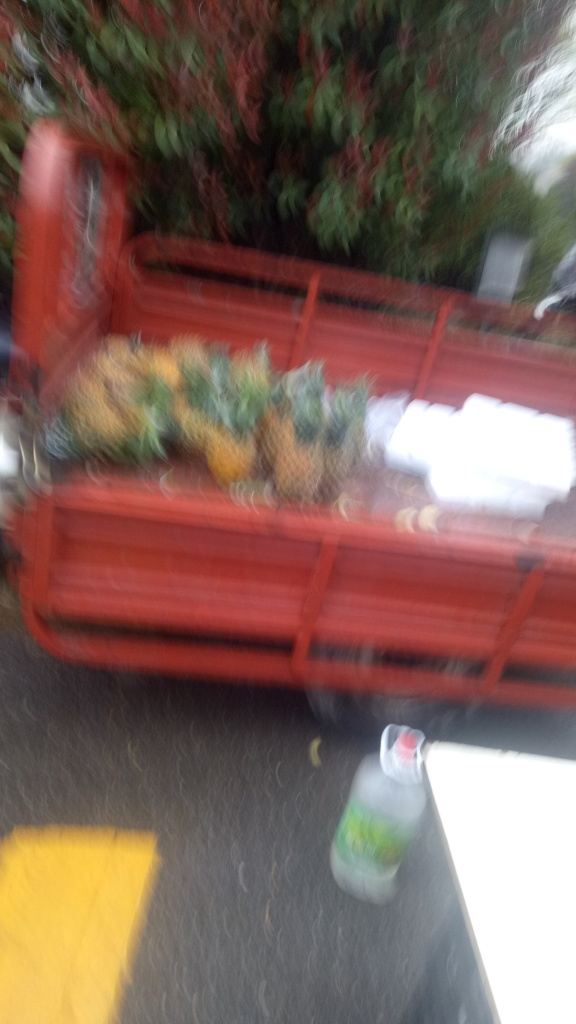Is the background clear?
A. Yes
B. Distinct
C. No
Answer with the option's letter from the given choices directly. The correct answer is C, No. The image is notably blurry, which obscures the details in the background and makes it difficult to discern any objects or scenery behind the main subject. This lack of clarity compromises our ability to analyze or appreciate the finer aspects of the picture's setting. 